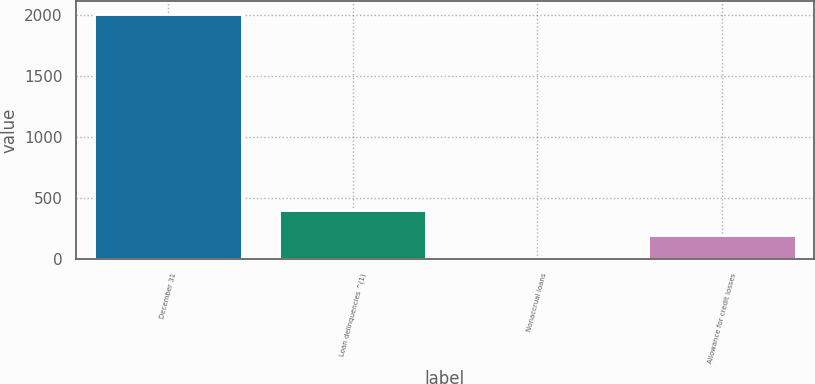Convert chart. <chart><loc_0><loc_0><loc_500><loc_500><bar_chart><fcel>December 31<fcel>Loan delinquencies ^(1)<fcel>Nonaccrual loans<fcel>Allowance for credit losses<nl><fcel>2008<fcel>401.71<fcel>0.13<fcel>200.92<nl></chart> 